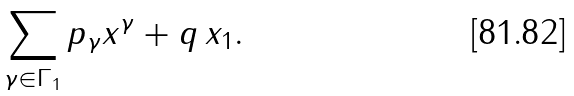Convert formula to latex. <formula><loc_0><loc_0><loc_500><loc_500>\sum _ { \gamma \in \Gamma _ { 1 } } p _ { \gamma } x ^ { \gamma } + q \, x _ { 1 } .</formula> 